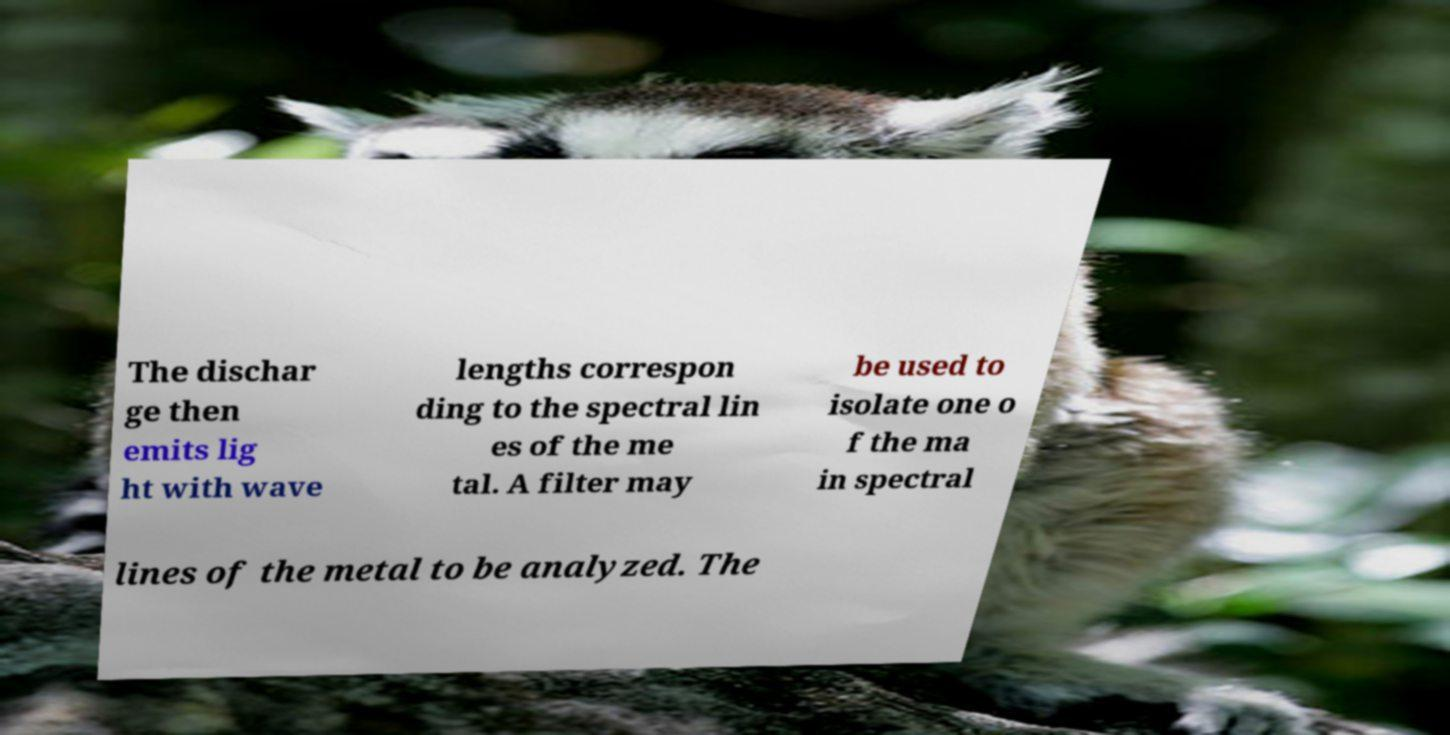For documentation purposes, I need the text within this image transcribed. Could you provide that? The dischar ge then emits lig ht with wave lengths correspon ding to the spectral lin es of the me tal. A filter may be used to isolate one o f the ma in spectral lines of the metal to be analyzed. The 